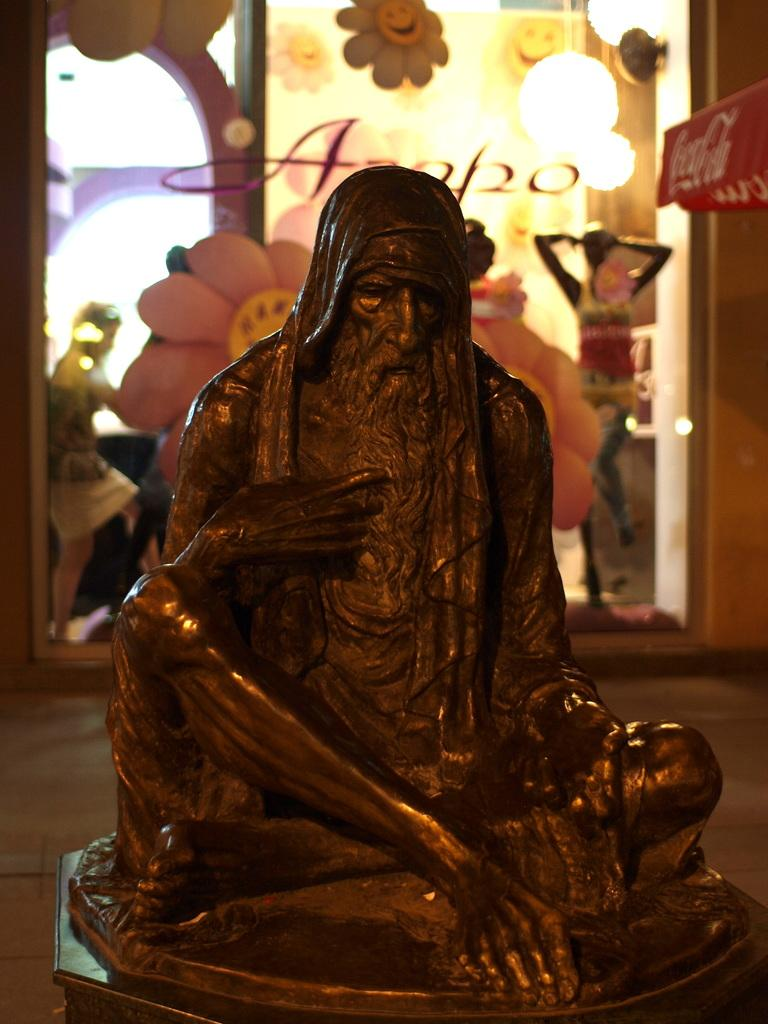What is the main subject in the front of the image? There is a statue in the front of the image. What can be seen in the background of the image? There are people and another statue in the background of the image. What type of kitten can be seen climbing the statue in the image? There is no kitten present in the image; it only features statues and people. 